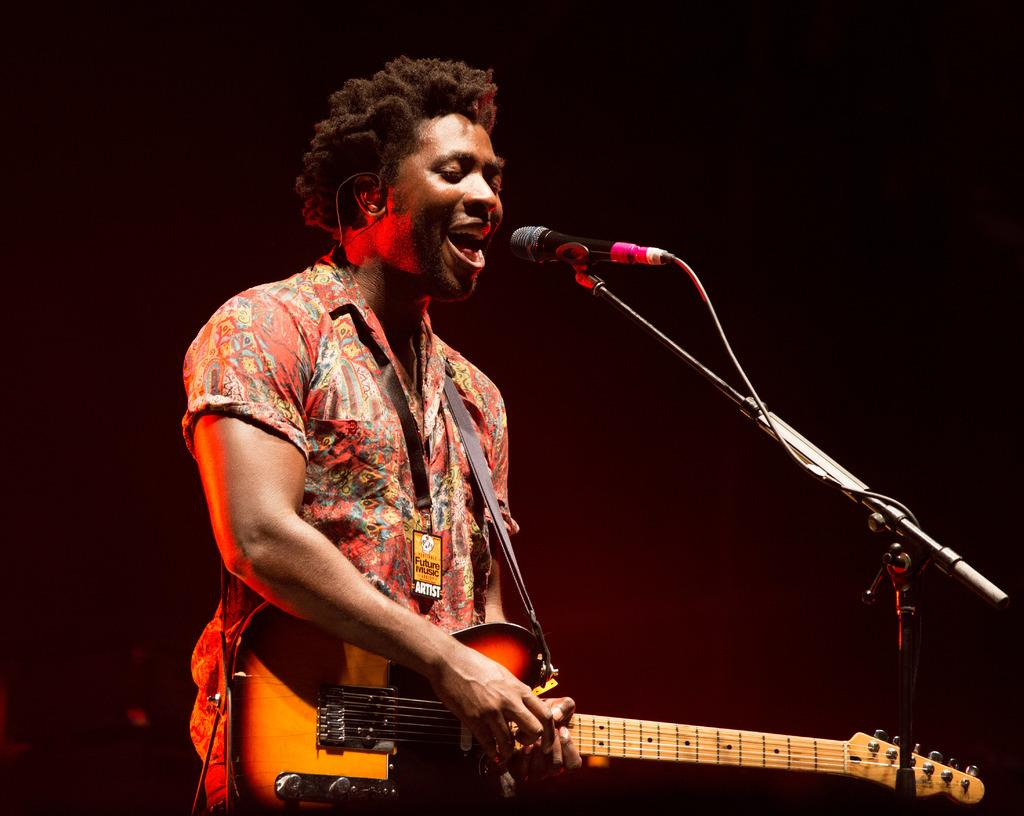What is the man in the image doing? The man is standing, playing a guitar, and singing, as indicated by his open mouth. What object is in front of the man? There is a microphone in front of the man. What can be observed about the background of the image? The background of the image is dark. What type of oatmeal is the man eating in the image? There is no oatmeal present in the image; the man is playing a guitar and singing. What discovery was made by the man in the image? There is no indication of a discovery in the image; the man is focused on playing his guitar and singing. 